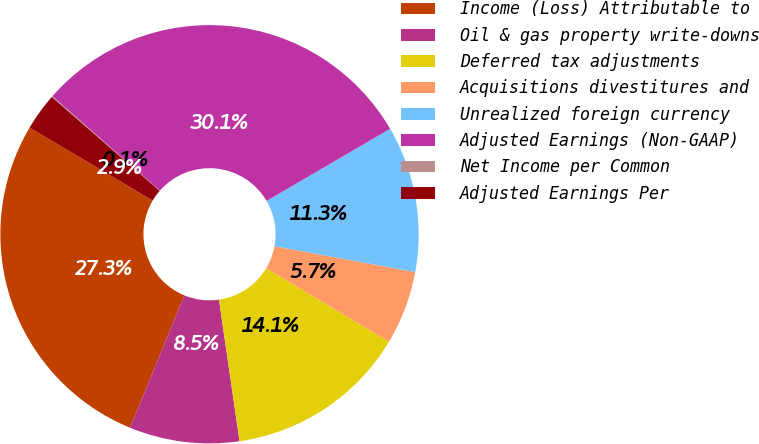<chart> <loc_0><loc_0><loc_500><loc_500><pie_chart><fcel>Income (Loss) Attributable to<fcel>Oil & gas property write-downs<fcel>Deferred tax adjustments<fcel>Acquisitions divestitures and<fcel>Unrealized foreign currency<fcel>Adjusted Earnings (Non-GAAP)<fcel>Net Income per Common<fcel>Adjusted Earnings Per<nl><fcel>27.31%<fcel>8.5%<fcel>14.12%<fcel>5.69%<fcel>11.31%<fcel>30.12%<fcel>0.07%<fcel>2.88%<nl></chart> 